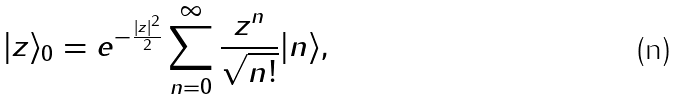Convert formula to latex. <formula><loc_0><loc_0><loc_500><loc_500>| z \rangle _ { 0 } = e ^ { - \frac { | z | ^ { 2 } } { 2 } } \sum _ { n = 0 } ^ { \infty } \frac { z ^ { n } } { \sqrt { n ! } } | n \rangle ,</formula> 